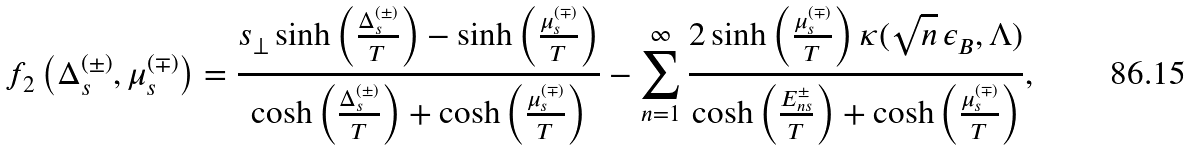<formula> <loc_0><loc_0><loc_500><loc_500>f _ { 2 } \left ( \Delta ^ { ( \pm ) } _ { s } , \mu ^ { ( \mp ) } _ { s } \right ) = \frac { s _ { \perp } \sinh \left ( \frac { \Delta ^ { ( \pm ) } _ { s } } { T } \right ) - \sinh \left ( \frac { \mu ^ { ( \mp ) } _ { s } } { T } \right ) } { \cosh \left ( \frac { \Delta ^ { ( \pm ) } _ { s } } { T } \right ) + \cosh \left ( \frac { \mu ^ { ( \mp ) } _ { s } } { T } \right ) } - \sum _ { n = 1 } ^ { \infty } \frac { 2 \sinh \left ( \frac { \mu ^ { ( \mp ) } _ { s } } { T } \right ) \kappa ( \sqrt { n } \, \epsilon _ { B } , \Lambda ) } { \cosh \left ( \frac { E _ { n s } ^ { \pm } } { T } \right ) + \cosh \left ( \frac { \mu ^ { ( \mp ) } _ { s } } { T } \right ) } ,</formula> 